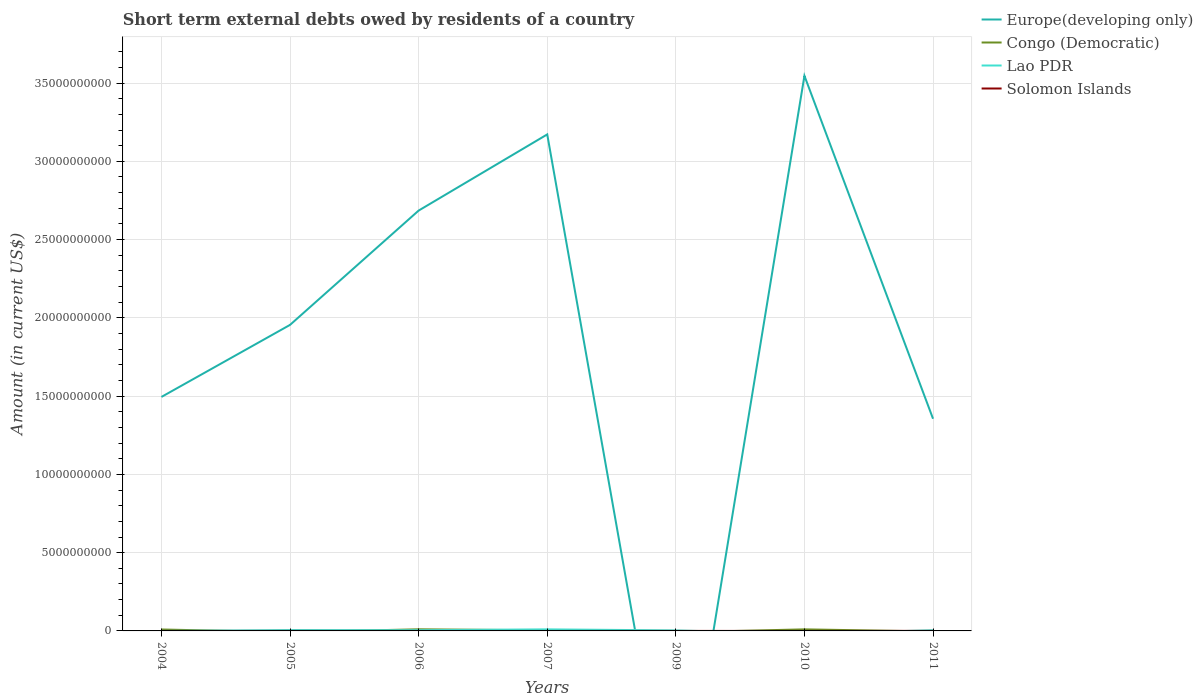How many different coloured lines are there?
Make the answer very short. 4. Is the number of lines equal to the number of legend labels?
Offer a very short reply. No. Across all years, what is the maximum amount of short-term external debts owed by residents in Europe(developing only)?
Make the answer very short. 0. What is the total amount of short-term external debts owed by residents in Congo (Democratic) in the graph?
Offer a terse response. -1.20e+07. What is the difference between the highest and the second highest amount of short-term external debts owed by residents in Europe(developing only)?
Your response must be concise. 3.55e+1. What is the difference between the highest and the lowest amount of short-term external debts owed by residents in Lao PDR?
Your answer should be very brief. 4. How many years are there in the graph?
Make the answer very short. 7. Does the graph contain grids?
Offer a terse response. Yes. Where does the legend appear in the graph?
Ensure brevity in your answer.  Top right. How many legend labels are there?
Provide a short and direct response. 4. How are the legend labels stacked?
Provide a short and direct response. Vertical. What is the title of the graph?
Your answer should be compact. Short term external debts owed by residents of a country. Does "Spain" appear as one of the legend labels in the graph?
Your response must be concise. No. What is the label or title of the Y-axis?
Your response must be concise. Amount (in current US$). What is the Amount (in current US$) of Europe(developing only) in 2004?
Keep it short and to the point. 1.49e+1. What is the Amount (in current US$) in Congo (Democratic) in 2004?
Offer a terse response. 9.20e+07. What is the Amount (in current US$) of Europe(developing only) in 2005?
Give a very brief answer. 1.96e+1. What is the Amount (in current US$) in Congo (Democratic) in 2005?
Provide a succinct answer. 0. What is the Amount (in current US$) of Lao PDR in 2005?
Your answer should be compact. 5.50e+07. What is the Amount (in current US$) in Europe(developing only) in 2006?
Your response must be concise. 2.69e+1. What is the Amount (in current US$) in Congo (Democratic) in 2006?
Offer a terse response. 1.04e+08. What is the Amount (in current US$) of Lao PDR in 2006?
Give a very brief answer. 4.80e+07. What is the Amount (in current US$) of Solomon Islands in 2006?
Provide a succinct answer. 0. What is the Amount (in current US$) of Europe(developing only) in 2007?
Provide a short and direct response. 3.17e+1. What is the Amount (in current US$) in Congo (Democratic) in 2007?
Offer a terse response. 3.80e+07. What is the Amount (in current US$) in Lao PDR in 2007?
Offer a very short reply. 1.00e+08. What is the Amount (in current US$) of Congo (Democratic) in 2009?
Your answer should be very brief. 0. What is the Amount (in current US$) of Lao PDR in 2009?
Make the answer very short. 3.30e+07. What is the Amount (in current US$) of Europe(developing only) in 2010?
Provide a short and direct response. 3.55e+1. What is the Amount (in current US$) of Congo (Democratic) in 2010?
Make the answer very short. 1.00e+08. What is the Amount (in current US$) in Lao PDR in 2010?
Your response must be concise. 0. What is the Amount (in current US$) in Solomon Islands in 2010?
Make the answer very short. 0. What is the Amount (in current US$) of Europe(developing only) in 2011?
Give a very brief answer. 1.36e+1. What is the Amount (in current US$) of Lao PDR in 2011?
Provide a succinct answer. 4.40e+07. Across all years, what is the maximum Amount (in current US$) in Europe(developing only)?
Provide a short and direct response. 3.55e+1. Across all years, what is the maximum Amount (in current US$) in Congo (Democratic)?
Give a very brief answer. 1.04e+08. Across all years, what is the maximum Amount (in current US$) of Solomon Islands?
Your response must be concise. 4.00e+06. Across all years, what is the minimum Amount (in current US$) of Europe(developing only)?
Keep it short and to the point. 0. Across all years, what is the minimum Amount (in current US$) in Congo (Democratic)?
Your response must be concise. 0. What is the total Amount (in current US$) of Europe(developing only) in the graph?
Provide a succinct answer. 1.42e+11. What is the total Amount (in current US$) in Congo (Democratic) in the graph?
Provide a short and direct response. 3.34e+08. What is the total Amount (in current US$) of Lao PDR in the graph?
Offer a terse response. 2.80e+08. What is the total Amount (in current US$) in Solomon Islands in the graph?
Ensure brevity in your answer.  7.00e+06. What is the difference between the Amount (in current US$) in Europe(developing only) in 2004 and that in 2005?
Give a very brief answer. -4.60e+09. What is the difference between the Amount (in current US$) of Europe(developing only) in 2004 and that in 2006?
Give a very brief answer. -1.19e+1. What is the difference between the Amount (in current US$) of Congo (Democratic) in 2004 and that in 2006?
Provide a succinct answer. -1.20e+07. What is the difference between the Amount (in current US$) of Europe(developing only) in 2004 and that in 2007?
Your response must be concise. -1.68e+1. What is the difference between the Amount (in current US$) in Congo (Democratic) in 2004 and that in 2007?
Give a very brief answer. 5.40e+07. What is the difference between the Amount (in current US$) in Europe(developing only) in 2004 and that in 2010?
Make the answer very short. -2.05e+1. What is the difference between the Amount (in current US$) in Congo (Democratic) in 2004 and that in 2010?
Ensure brevity in your answer.  -8.00e+06. What is the difference between the Amount (in current US$) of Europe(developing only) in 2004 and that in 2011?
Provide a short and direct response. 1.39e+09. What is the difference between the Amount (in current US$) of Europe(developing only) in 2005 and that in 2006?
Keep it short and to the point. -7.30e+09. What is the difference between the Amount (in current US$) of Europe(developing only) in 2005 and that in 2007?
Offer a terse response. -1.22e+1. What is the difference between the Amount (in current US$) in Lao PDR in 2005 and that in 2007?
Make the answer very short. -4.50e+07. What is the difference between the Amount (in current US$) in Lao PDR in 2005 and that in 2009?
Ensure brevity in your answer.  2.20e+07. What is the difference between the Amount (in current US$) in Solomon Islands in 2005 and that in 2009?
Keep it short and to the point. 1.00e+06. What is the difference between the Amount (in current US$) of Europe(developing only) in 2005 and that in 2010?
Keep it short and to the point. -1.59e+1. What is the difference between the Amount (in current US$) of Europe(developing only) in 2005 and that in 2011?
Provide a succinct answer. 6.00e+09. What is the difference between the Amount (in current US$) of Lao PDR in 2005 and that in 2011?
Your response must be concise. 1.10e+07. What is the difference between the Amount (in current US$) of Europe(developing only) in 2006 and that in 2007?
Ensure brevity in your answer.  -4.87e+09. What is the difference between the Amount (in current US$) of Congo (Democratic) in 2006 and that in 2007?
Keep it short and to the point. 6.60e+07. What is the difference between the Amount (in current US$) of Lao PDR in 2006 and that in 2007?
Give a very brief answer. -5.20e+07. What is the difference between the Amount (in current US$) of Lao PDR in 2006 and that in 2009?
Provide a short and direct response. 1.50e+07. What is the difference between the Amount (in current US$) in Europe(developing only) in 2006 and that in 2010?
Your answer should be very brief. -8.61e+09. What is the difference between the Amount (in current US$) in Congo (Democratic) in 2006 and that in 2010?
Your answer should be compact. 4.00e+06. What is the difference between the Amount (in current US$) of Europe(developing only) in 2006 and that in 2011?
Offer a very short reply. 1.33e+1. What is the difference between the Amount (in current US$) in Lao PDR in 2007 and that in 2009?
Ensure brevity in your answer.  6.70e+07. What is the difference between the Amount (in current US$) of Europe(developing only) in 2007 and that in 2010?
Ensure brevity in your answer.  -3.74e+09. What is the difference between the Amount (in current US$) of Congo (Democratic) in 2007 and that in 2010?
Provide a short and direct response. -6.20e+07. What is the difference between the Amount (in current US$) of Europe(developing only) in 2007 and that in 2011?
Your answer should be compact. 1.82e+1. What is the difference between the Amount (in current US$) in Lao PDR in 2007 and that in 2011?
Offer a terse response. 5.60e+07. What is the difference between the Amount (in current US$) of Lao PDR in 2009 and that in 2011?
Make the answer very short. -1.10e+07. What is the difference between the Amount (in current US$) of Solomon Islands in 2009 and that in 2011?
Offer a terse response. -3.00e+06. What is the difference between the Amount (in current US$) in Europe(developing only) in 2010 and that in 2011?
Give a very brief answer. 2.19e+1. What is the difference between the Amount (in current US$) of Europe(developing only) in 2004 and the Amount (in current US$) of Lao PDR in 2005?
Offer a terse response. 1.49e+1. What is the difference between the Amount (in current US$) of Europe(developing only) in 2004 and the Amount (in current US$) of Solomon Islands in 2005?
Provide a short and direct response. 1.49e+1. What is the difference between the Amount (in current US$) in Congo (Democratic) in 2004 and the Amount (in current US$) in Lao PDR in 2005?
Provide a short and direct response. 3.70e+07. What is the difference between the Amount (in current US$) of Congo (Democratic) in 2004 and the Amount (in current US$) of Solomon Islands in 2005?
Keep it short and to the point. 9.00e+07. What is the difference between the Amount (in current US$) in Europe(developing only) in 2004 and the Amount (in current US$) in Congo (Democratic) in 2006?
Your answer should be compact. 1.48e+1. What is the difference between the Amount (in current US$) in Europe(developing only) in 2004 and the Amount (in current US$) in Lao PDR in 2006?
Make the answer very short. 1.49e+1. What is the difference between the Amount (in current US$) in Congo (Democratic) in 2004 and the Amount (in current US$) in Lao PDR in 2006?
Give a very brief answer. 4.40e+07. What is the difference between the Amount (in current US$) of Europe(developing only) in 2004 and the Amount (in current US$) of Congo (Democratic) in 2007?
Your answer should be compact. 1.49e+1. What is the difference between the Amount (in current US$) in Europe(developing only) in 2004 and the Amount (in current US$) in Lao PDR in 2007?
Give a very brief answer. 1.48e+1. What is the difference between the Amount (in current US$) of Congo (Democratic) in 2004 and the Amount (in current US$) of Lao PDR in 2007?
Your answer should be compact. -8.00e+06. What is the difference between the Amount (in current US$) of Europe(developing only) in 2004 and the Amount (in current US$) of Lao PDR in 2009?
Offer a very short reply. 1.49e+1. What is the difference between the Amount (in current US$) in Europe(developing only) in 2004 and the Amount (in current US$) in Solomon Islands in 2009?
Your answer should be compact. 1.49e+1. What is the difference between the Amount (in current US$) of Congo (Democratic) in 2004 and the Amount (in current US$) of Lao PDR in 2009?
Provide a short and direct response. 5.90e+07. What is the difference between the Amount (in current US$) in Congo (Democratic) in 2004 and the Amount (in current US$) in Solomon Islands in 2009?
Give a very brief answer. 9.10e+07. What is the difference between the Amount (in current US$) in Europe(developing only) in 2004 and the Amount (in current US$) in Congo (Democratic) in 2010?
Provide a short and direct response. 1.48e+1. What is the difference between the Amount (in current US$) of Europe(developing only) in 2004 and the Amount (in current US$) of Lao PDR in 2011?
Give a very brief answer. 1.49e+1. What is the difference between the Amount (in current US$) of Europe(developing only) in 2004 and the Amount (in current US$) of Solomon Islands in 2011?
Your answer should be compact. 1.49e+1. What is the difference between the Amount (in current US$) in Congo (Democratic) in 2004 and the Amount (in current US$) in Lao PDR in 2011?
Provide a succinct answer. 4.80e+07. What is the difference between the Amount (in current US$) of Congo (Democratic) in 2004 and the Amount (in current US$) of Solomon Islands in 2011?
Give a very brief answer. 8.80e+07. What is the difference between the Amount (in current US$) of Europe(developing only) in 2005 and the Amount (in current US$) of Congo (Democratic) in 2006?
Keep it short and to the point. 1.94e+1. What is the difference between the Amount (in current US$) of Europe(developing only) in 2005 and the Amount (in current US$) of Lao PDR in 2006?
Offer a terse response. 1.95e+1. What is the difference between the Amount (in current US$) of Europe(developing only) in 2005 and the Amount (in current US$) of Congo (Democratic) in 2007?
Ensure brevity in your answer.  1.95e+1. What is the difference between the Amount (in current US$) of Europe(developing only) in 2005 and the Amount (in current US$) of Lao PDR in 2007?
Ensure brevity in your answer.  1.95e+1. What is the difference between the Amount (in current US$) of Europe(developing only) in 2005 and the Amount (in current US$) of Lao PDR in 2009?
Make the answer very short. 1.95e+1. What is the difference between the Amount (in current US$) in Europe(developing only) in 2005 and the Amount (in current US$) in Solomon Islands in 2009?
Keep it short and to the point. 1.96e+1. What is the difference between the Amount (in current US$) in Lao PDR in 2005 and the Amount (in current US$) in Solomon Islands in 2009?
Ensure brevity in your answer.  5.40e+07. What is the difference between the Amount (in current US$) in Europe(developing only) in 2005 and the Amount (in current US$) in Congo (Democratic) in 2010?
Your answer should be very brief. 1.95e+1. What is the difference between the Amount (in current US$) of Europe(developing only) in 2005 and the Amount (in current US$) of Lao PDR in 2011?
Provide a succinct answer. 1.95e+1. What is the difference between the Amount (in current US$) of Europe(developing only) in 2005 and the Amount (in current US$) of Solomon Islands in 2011?
Make the answer very short. 1.95e+1. What is the difference between the Amount (in current US$) of Lao PDR in 2005 and the Amount (in current US$) of Solomon Islands in 2011?
Keep it short and to the point. 5.10e+07. What is the difference between the Amount (in current US$) of Europe(developing only) in 2006 and the Amount (in current US$) of Congo (Democratic) in 2007?
Offer a terse response. 2.68e+1. What is the difference between the Amount (in current US$) in Europe(developing only) in 2006 and the Amount (in current US$) in Lao PDR in 2007?
Ensure brevity in your answer.  2.68e+1. What is the difference between the Amount (in current US$) in Congo (Democratic) in 2006 and the Amount (in current US$) in Lao PDR in 2007?
Your answer should be very brief. 4.00e+06. What is the difference between the Amount (in current US$) in Europe(developing only) in 2006 and the Amount (in current US$) in Lao PDR in 2009?
Give a very brief answer. 2.68e+1. What is the difference between the Amount (in current US$) in Europe(developing only) in 2006 and the Amount (in current US$) in Solomon Islands in 2009?
Your answer should be very brief. 2.69e+1. What is the difference between the Amount (in current US$) of Congo (Democratic) in 2006 and the Amount (in current US$) of Lao PDR in 2009?
Offer a terse response. 7.10e+07. What is the difference between the Amount (in current US$) of Congo (Democratic) in 2006 and the Amount (in current US$) of Solomon Islands in 2009?
Keep it short and to the point. 1.03e+08. What is the difference between the Amount (in current US$) in Lao PDR in 2006 and the Amount (in current US$) in Solomon Islands in 2009?
Your answer should be very brief. 4.70e+07. What is the difference between the Amount (in current US$) of Europe(developing only) in 2006 and the Amount (in current US$) of Congo (Democratic) in 2010?
Provide a short and direct response. 2.68e+1. What is the difference between the Amount (in current US$) of Europe(developing only) in 2006 and the Amount (in current US$) of Lao PDR in 2011?
Your response must be concise. 2.68e+1. What is the difference between the Amount (in current US$) in Europe(developing only) in 2006 and the Amount (in current US$) in Solomon Islands in 2011?
Make the answer very short. 2.69e+1. What is the difference between the Amount (in current US$) of Congo (Democratic) in 2006 and the Amount (in current US$) of Lao PDR in 2011?
Make the answer very short. 6.00e+07. What is the difference between the Amount (in current US$) in Congo (Democratic) in 2006 and the Amount (in current US$) in Solomon Islands in 2011?
Your answer should be very brief. 1.00e+08. What is the difference between the Amount (in current US$) in Lao PDR in 2006 and the Amount (in current US$) in Solomon Islands in 2011?
Provide a short and direct response. 4.40e+07. What is the difference between the Amount (in current US$) in Europe(developing only) in 2007 and the Amount (in current US$) in Lao PDR in 2009?
Provide a succinct answer. 3.17e+1. What is the difference between the Amount (in current US$) in Europe(developing only) in 2007 and the Amount (in current US$) in Solomon Islands in 2009?
Offer a very short reply. 3.17e+1. What is the difference between the Amount (in current US$) in Congo (Democratic) in 2007 and the Amount (in current US$) in Solomon Islands in 2009?
Provide a short and direct response. 3.70e+07. What is the difference between the Amount (in current US$) of Lao PDR in 2007 and the Amount (in current US$) of Solomon Islands in 2009?
Offer a terse response. 9.90e+07. What is the difference between the Amount (in current US$) of Europe(developing only) in 2007 and the Amount (in current US$) of Congo (Democratic) in 2010?
Your answer should be very brief. 3.16e+1. What is the difference between the Amount (in current US$) in Europe(developing only) in 2007 and the Amount (in current US$) in Lao PDR in 2011?
Your response must be concise. 3.17e+1. What is the difference between the Amount (in current US$) in Europe(developing only) in 2007 and the Amount (in current US$) in Solomon Islands in 2011?
Offer a very short reply. 3.17e+1. What is the difference between the Amount (in current US$) of Congo (Democratic) in 2007 and the Amount (in current US$) of Lao PDR in 2011?
Provide a succinct answer. -6.00e+06. What is the difference between the Amount (in current US$) of Congo (Democratic) in 2007 and the Amount (in current US$) of Solomon Islands in 2011?
Your answer should be compact. 3.40e+07. What is the difference between the Amount (in current US$) in Lao PDR in 2007 and the Amount (in current US$) in Solomon Islands in 2011?
Ensure brevity in your answer.  9.60e+07. What is the difference between the Amount (in current US$) in Lao PDR in 2009 and the Amount (in current US$) in Solomon Islands in 2011?
Your answer should be very brief. 2.90e+07. What is the difference between the Amount (in current US$) of Europe(developing only) in 2010 and the Amount (in current US$) of Lao PDR in 2011?
Offer a terse response. 3.54e+1. What is the difference between the Amount (in current US$) in Europe(developing only) in 2010 and the Amount (in current US$) in Solomon Islands in 2011?
Your answer should be very brief. 3.55e+1. What is the difference between the Amount (in current US$) in Congo (Democratic) in 2010 and the Amount (in current US$) in Lao PDR in 2011?
Make the answer very short. 5.60e+07. What is the difference between the Amount (in current US$) of Congo (Democratic) in 2010 and the Amount (in current US$) of Solomon Islands in 2011?
Make the answer very short. 9.60e+07. What is the average Amount (in current US$) in Europe(developing only) per year?
Your response must be concise. 2.03e+1. What is the average Amount (in current US$) of Congo (Democratic) per year?
Provide a succinct answer. 4.77e+07. What is the average Amount (in current US$) of Lao PDR per year?
Your answer should be very brief. 4.00e+07. In the year 2004, what is the difference between the Amount (in current US$) of Europe(developing only) and Amount (in current US$) of Congo (Democratic)?
Provide a succinct answer. 1.49e+1. In the year 2005, what is the difference between the Amount (in current US$) in Europe(developing only) and Amount (in current US$) in Lao PDR?
Your answer should be very brief. 1.95e+1. In the year 2005, what is the difference between the Amount (in current US$) in Europe(developing only) and Amount (in current US$) in Solomon Islands?
Your answer should be very brief. 1.95e+1. In the year 2005, what is the difference between the Amount (in current US$) of Lao PDR and Amount (in current US$) of Solomon Islands?
Make the answer very short. 5.30e+07. In the year 2006, what is the difference between the Amount (in current US$) in Europe(developing only) and Amount (in current US$) in Congo (Democratic)?
Offer a very short reply. 2.68e+1. In the year 2006, what is the difference between the Amount (in current US$) of Europe(developing only) and Amount (in current US$) of Lao PDR?
Your answer should be very brief. 2.68e+1. In the year 2006, what is the difference between the Amount (in current US$) of Congo (Democratic) and Amount (in current US$) of Lao PDR?
Your response must be concise. 5.60e+07. In the year 2007, what is the difference between the Amount (in current US$) of Europe(developing only) and Amount (in current US$) of Congo (Democratic)?
Your answer should be compact. 3.17e+1. In the year 2007, what is the difference between the Amount (in current US$) in Europe(developing only) and Amount (in current US$) in Lao PDR?
Keep it short and to the point. 3.16e+1. In the year 2007, what is the difference between the Amount (in current US$) in Congo (Democratic) and Amount (in current US$) in Lao PDR?
Your response must be concise. -6.20e+07. In the year 2009, what is the difference between the Amount (in current US$) of Lao PDR and Amount (in current US$) of Solomon Islands?
Give a very brief answer. 3.20e+07. In the year 2010, what is the difference between the Amount (in current US$) in Europe(developing only) and Amount (in current US$) in Congo (Democratic)?
Provide a short and direct response. 3.54e+1. In the year 2011, what is the difference between the Amount (in current US$) of Europe(developing only) and Amount (in current US$) of Lao PDR?
Offer a very short reply. 1.35e+1. In the year 2011, what is the difference between the Amount (in current US$) of Europe(developing only) and Amount (in current US$) of Solomon Islands?
Offer a terse response. 1.36e+1. In the year 2011, what is the difference between the Amount (in current US$) of Lao PDR and Amount (in current US$) of Solomon Islands?
Ensure brevity in your answer.  4.00e+07. What is the ratio of the Amount (in current US$) in Europe(developing only) in 2004 to that in 2005?
Offer a very short reply. 0.76. What is the ratio of the Amount (in current US$) of Europe(developing only) in 2004 to that in 2006?
Your response must be concise. 0.56. What is the ratio of the Amount (in current US$) of Congo (Democratic) in 2004 to that in 2006?
Your answer should be compact. 0.88. What is the ratio of the Amount (in current US$) in Europe(developing only) in 2004 to that in 2007?
Ensure brevity in your answer.  0.47. What is the ratio of the Amount (in current US$) in Congo (Democratic) in 2004 to that in 2007?
Ensure brevity in your answer.  2.42. What is the ratio of the Amount (in current US$) of Europe(developing only) in 2004 to that in 2010?
Provide a succinct answer. 0.42. What is the ratio of the Amount (in current US$) of Europe(developing only) in 2004 to that in 2011?
Your response must be concise. 1.1. What is the ratio of the Amount (in current US$) of Europe(developing only) in 2005 to that in 2006?
Keep it short and to the point. 0.73. What is the ratio of the Amount (in current US$) of Lao PDR in 2005 to that in 2006?
Your answer should be very brief. 1.15. What is the ratio of the Amount (in current US$) of Europe(developing only) in 2005 to that in 2007?
Provide a succinct answer. 0.62. What is the ratio of the Amount (in current US$) in Lao PDR in 2005 to that in 2007?
Your answer should be compact. 0.55. What is the ratio of the Amount (in current US$) of Europe(developing only) in 2005 to that in 2010?
Offer a very short reply. 0.55. What is the ratio of the Amount (in current US$) of Europe(developing only) in 2005 to that in 2011?
Offer a very short reply. 1.44. What is the ratio of the Amount (in current US$) in Lao PDR in 2005 to that in 2011?
Provide a succinct answer. 1.25. What is the ratio of the Amount (in current US$) of Europe(developing only) in 2006 to that in 2007?
Provide a short and direct response. 0.85. What is the ratio of the Amount (in current US$) of Congo (Democratic) in 2006 to that in 2007?
Ensure brevity in your answer.  2.74. What is the ratio of the Amount (in current US$) of Lao PDR in 2006 to that in 2007?
Ensure brevity in your answer.  0.48. What is the ratio of the Amount (in current US$) of Lao PDR in 2006 to that in 2009?
Ensure brevity in your answer.  1.45. What is the ratio of the Amount (in current US$) of Europe(developing only) in 2006 to that in 2010?
Ensure brevity in your answer.  0.76. What is the ratio of the Amount (in current US$) of Europe(developing only) in 2006 to that in 2011?
Offer a very short reply. 1.98. What is the ratio of the Amount (in current US$) in Lao PDR in 2007 to that in 2009?
Offer a very short reply. 3.03. What is the ratio of the Amount (in current US$) in Europe(developing only) in 2007 to that in 2010?
Your response must be concise. 0.89. What is the ratio of the Amount (in current US$) of Congo (Democratic) in 2007 to that in 2010?
Offer a very short reply. 0.38. What is the ratio of the Amount (in current US$) in Europe(developing only) in 2007 to that in 2011?
Your answer should be compact. 2.34. What is the ratio of the Amount (in current US$) of Lao PDR in 2007 to that in 2011?
Ensure brevity in your answer.  2.27. What is the ratio of the Amount (in current US$) in Europe(developing only) in 2010 to that in 2011?
Provide a short and direct response. 2.62. What is the difference between the highest and the second highest Amount (in current US$) of Europe(developing only)?
Ensure brevity in your answer.  3.74e+09. What is the difference between the highest and the second highest Amount (in current US$) in Lao PDR?
Provide a short and direct response. 4.50e+07. What is the difference between the highest and the lowest Amount (in current US$) of Europe(developing only)?
Provide a succinct answer. 3.55e+1. What is the difference between the highest and the lowest Amount (in current US$) in Congo (Democratic)?
Your answer should be very brief. 1.04e+08. What is the difference between the highest and the lowest Amount (in current US$) in Lao PDR?
Provide a succinct answer. 1.00e+08. What is the difference between the highest and the lowest Amount (in current US$) of Solomon Islands?
Offer a very short reply. 4.00e+06. 